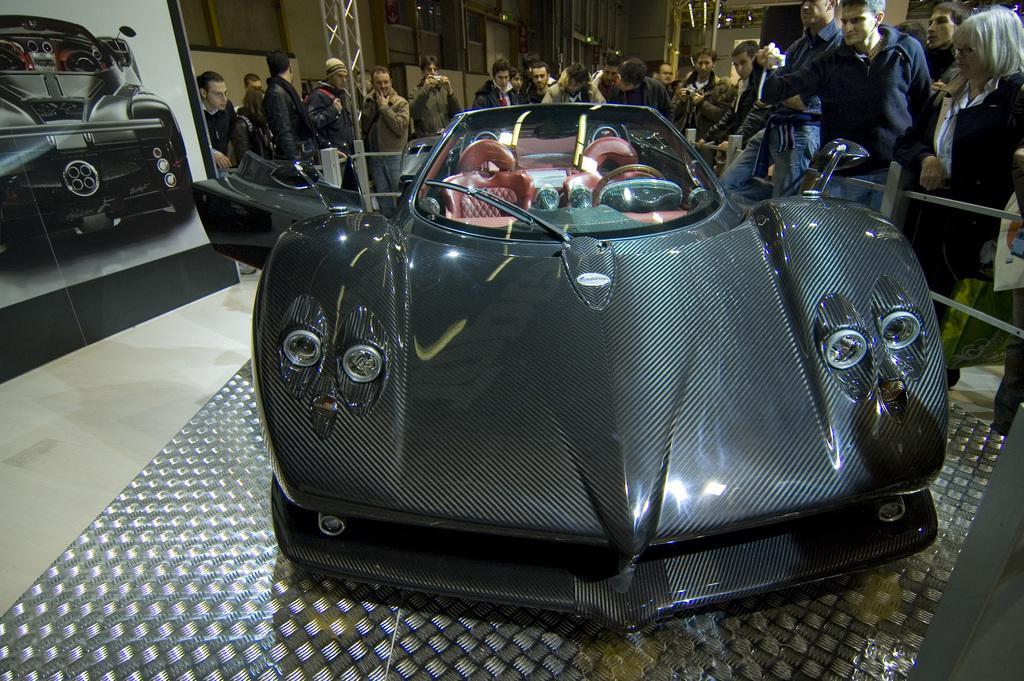Can you describe this image briefly? On the right side of the image we can see a poster of a car and some persons are there. In the middle of the image we can see a black color car. On the right side of the image we can see some persons are standing and one person is taking a photograph. 